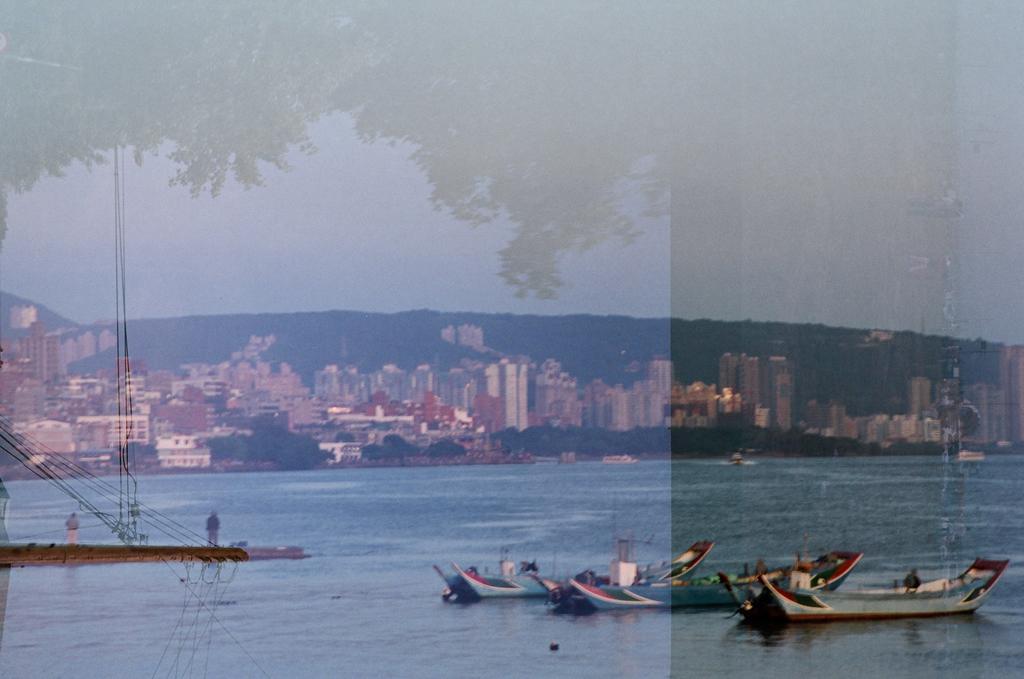Can you describe this image briefly? In this picture I can see some boats on the lake. On the left there are two persons who are standing on the bridge. In the background I can see many buildings, trees and mountain. At the top I can see the sky. 